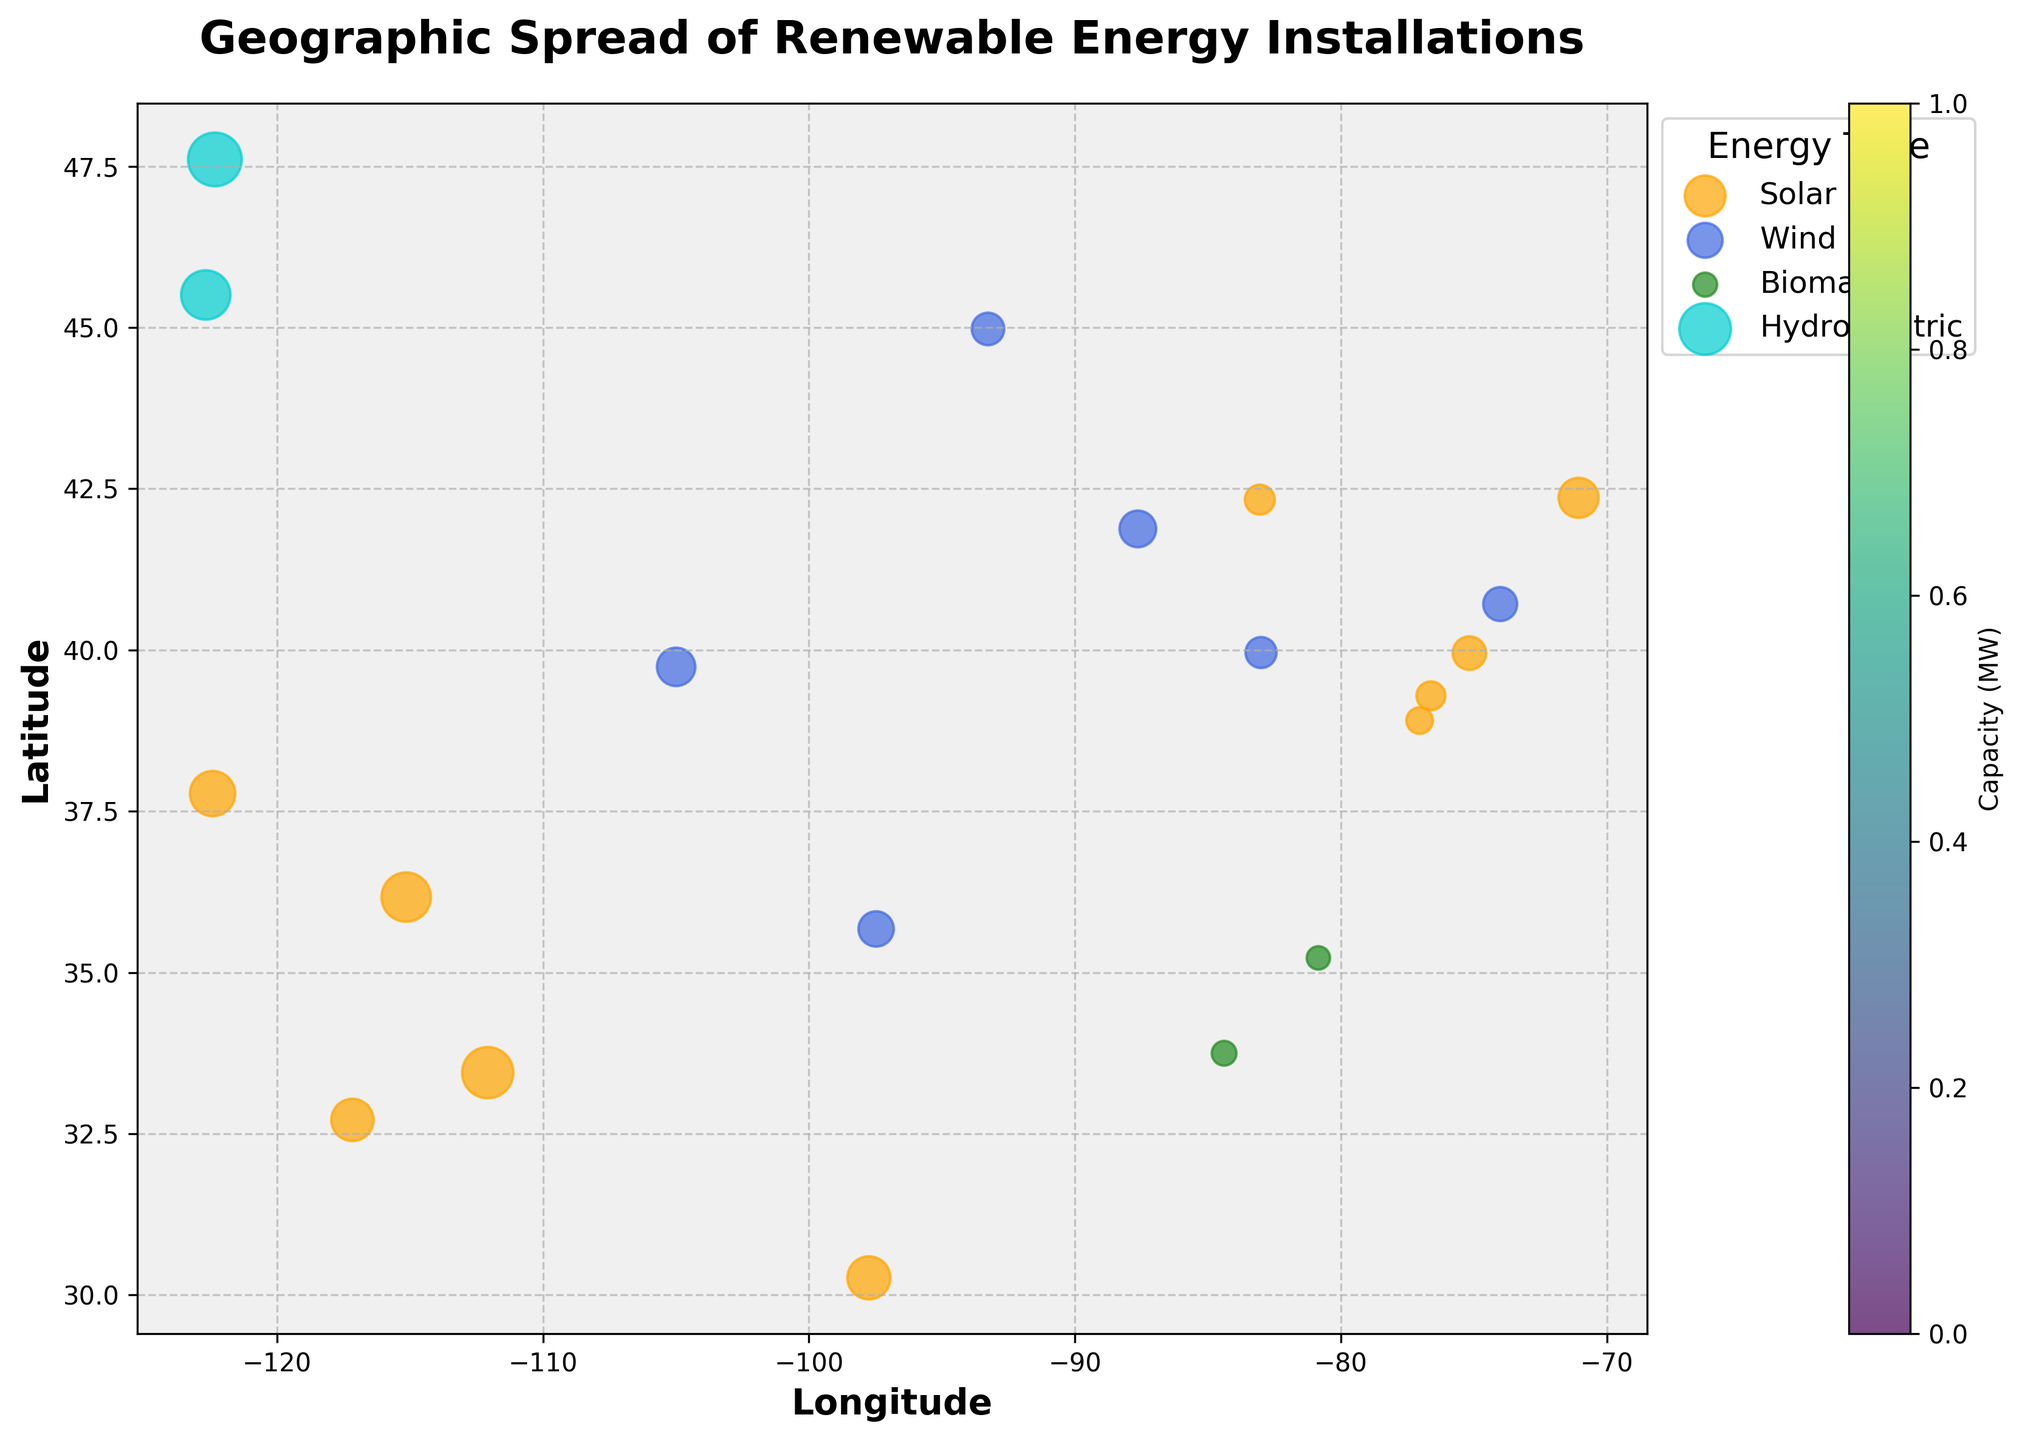Which type of renewable energy installation is most frequently represented in the figure? By counting the number of color-coded dots for each energy type in the scatter plot, we can identify that the most frequently represented energy type is Solar.
Answer: Solar How many installations are represented in the New York City area? By looking at the scatter plot, we see that there are installations located at the coordinates approximately corresponding to New York City (-74.0060, 40.7128). Counting these points reveals there is 1 installation.
Answer: 1 Which energy type has the highest capacity in one installation? From the scatter plot, locate the largest data point based on size and its corresponding color. The largest data point indicates a Hydroelectric installation in Seattle, WA, represented by a blue-green color with a capacity of 450MW.
Answer: Hydroelectric What is the range of latitudes represented in the figure? The latitude axis in the scatter plot shows data points ranging from approximately 32°N to 48°N.
Answer: 32°N to 48°N Which city has the highest capacity of Solar energy installations? By identifying the locations with Solar installations (marked in orange) and comparing their circle sizes, the largest one is found near Las Vegas, NV with a capacity of 380MW.
Answer: Las Vegas, NV Are there more Wind or Biomass installations represented in the figure? By counting the number of dots colored for Wind and Biomass and comparing them, we can see that Wind installations are more frequent than Biomass.
Answer: Wind What is the sum of capacities for Wind installations in the figure? Summing the capacities of all Wind installations (180 + 210 + 230 + 195 + 165 + 150) results in a total capacity of 1130MW.
Answer: 1130MW Which region of the country has the highest concentration of renewable energy installations? By visually examining which geographical region has the most densely packed data points, the West Coast notably around California and Washington stands out as being the most densely populated with installations.
Answer: West Coast How does the size of the smallest Solar installation compare to the smallest Wind installation? By comparing the smallest dots for Solar and Wind energies in the scatter plot, the smallest Solar installation is 110MW while the smallest Wind installation is 150MW.
Answer: Solar (110MW) < Wind (150MW) Is there a clear visual trend indicating a concentration of a specific energy type along any coastlines? By examining coastal areas in the scatter plot, we see that Solar installations are concentrated along the West Coast while Wind installations are more often inland or on the East Coast.
Answer: Yes, Solar on the West Coast 